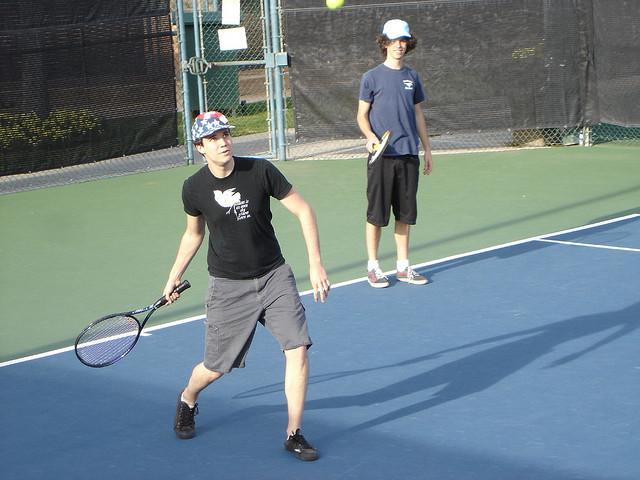What countries flag is on the man in the black shirts hat? Please explain your reasoning. united states. Red, white and blue, stars and stripes. 